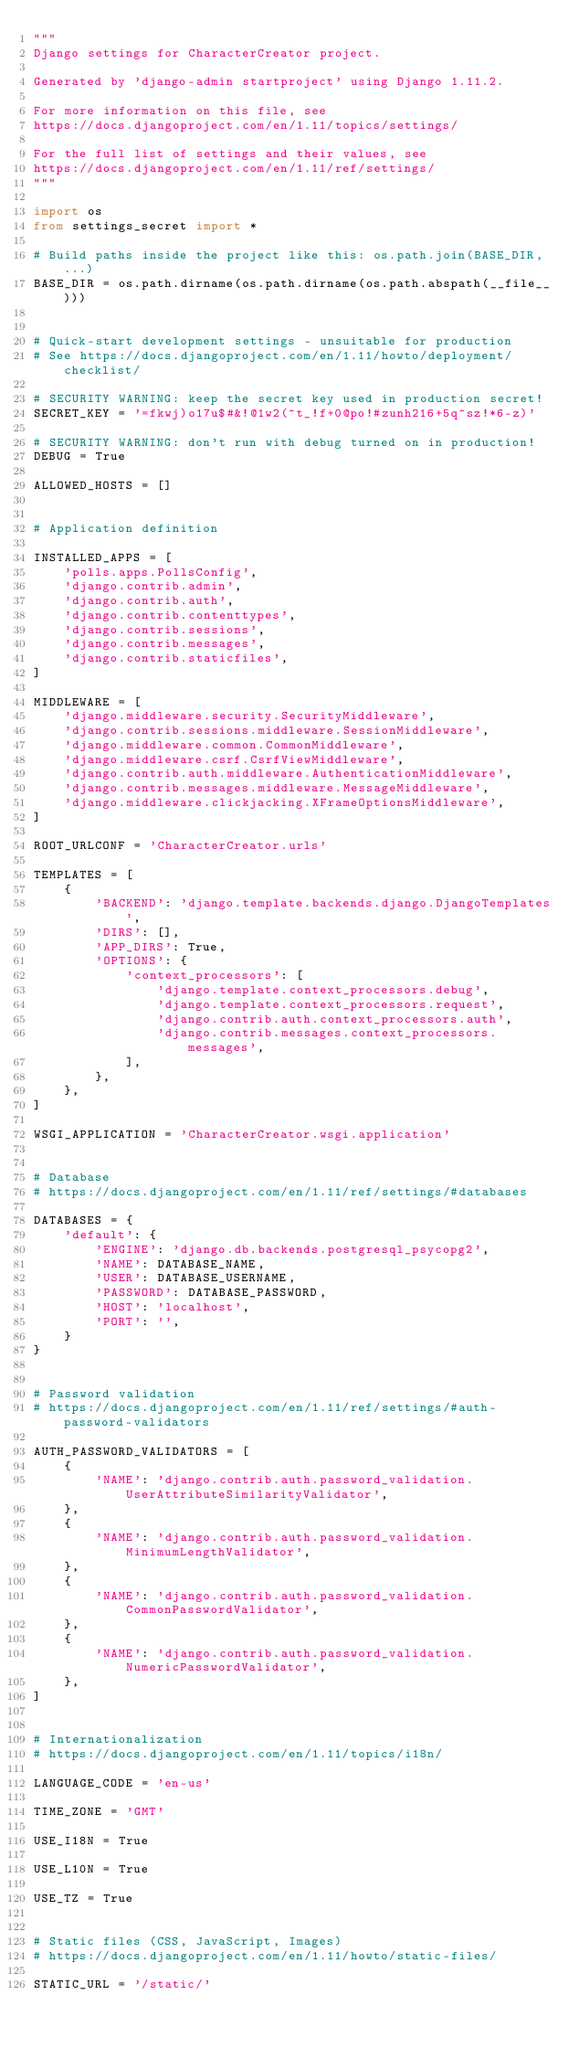<code> <loc_0><loc_0><loc_500><loc_500><_Python_>"""
Django settings for CharacterCreator project.

Generated by 'django-admin startproject' using Django 1.11.2.

For more information on this file, see
https://docs.djangoproject.com/en/1.11/topics/settings/

For the full list of settings and their values, see
https://docs.djangoproject.com/en/1.11/ref/settings/
"""

import os
from settings_secret import *

# Build paths inside the project like this: os.path.join(BASE_DIR, ...)
BASE_DIR = os.path.dirname(os.path.dirname(os.path.abspath(__file__)))


# Quick-start development settings - unsuitable for production
# See https://docs.djangoproject.com/en/1.11/howto/deployment/checklist/

# SECURITY WARNING: keep the secret key used in production secret!
SECRET_KEY = '=fkwj)o17u$#&!@1w2(^t_!f+0@po!#zunh216+5q^sz!*6-z)'

# SECURITY WARNING: don't run with debug turned on in production!
DEBUG = True

ALLOWED_HOSTS = []


# Application definition

INSTALLED_APPS = [
    'polls.apps.PollsConfig',
    'django.contrib.admin',
    'django.contrib.auth',
    'django.contrib.contenttypes',
    'django.contrib.sessions',
    'django.contrib.messages',
    'django.contrib.staticfiles',
]

MIDDLEWARE = [
    'django.middleware.security.SecurityMiddleware',
    'django.contrib.sessions.middleware.SessionMiddleware',
    'django.middleware.common.CommonMiddleware',
    'django.middleware.csrf.CsrfViewMiddleware',
    'django.contrib.auth.middleware.AuthenticationMiddleware',
    'django.contrib.messages.middleware.MessageMiddleware',
    'django.middleware.clickjacking.XFrameOptionsMiddleware',
]

ROOT_URLCONF = 'CharacterCreator.urls'

TEMPLATES = [
    {
        'BACKEND': 'django.template.backends.django.DjangoTemplates',
        'DIRS': [],
        'APP_DIRS': True,
        'OPTIONS': {
            'context_processors': [
                'django.template.context_processors.debug',
                'django.template.context_processors.request',
                'django.contrib.auth.context_processors.auth',
                'django.contrib.messages.context_processors.messages',
            ],
        },
    },
]

WSGI_APPLICATION = 'CharacterCreator.wsgi.application'


# Database
# https://docs.djangoproject.com/en/1.11/ref/settings/#databases

DATABASES = {
    'default': {
        'ENGINE': 'django.db.backends.postgresql_psycopg2',
        'NAME': DATABASE_NAME,
        'USER': DATABASE_USERNAME,
        'PASSWORD': DATABASE_PASSWORD,
        'HOST': 'localhost',
        'PORT': '',
    }
}


# Password validation
# https://docs.djangoproject.com/en/1.11/ref/settings/#auth-password-validators

AUTH_PASSWORD_VALIDATORS = [
    {
        'NAME': 'django.contrib.auth.password_validation.UserAttributeSimilarityValidator',
    },
    {
        'NAME': 'django.contrib.auth.password_validation.MinimumLengthValidator',
    },
    {
        'NAME': 'django.contrib.auth.password_validation.CommonPasswordValidator',
    },
    {
        'NAME': 'django.contrib.auth.password_validation.NumericPasswordValidator',
    },
]


# Internationalization
# https://docs.djangoproject.com/en/1.11/topics/i18n/

LANGUAGE_CODE = 'en-us'

TIME_ZONE = 'GMT'

USE_I18N = True

USE_L10N = True

USE_TZ = True


# Static files (CSS, JavaScript, Images)
# https://docs.djangoproject.com/en/1.11/howto/static-files/

STATIC_URL = '/static/'
</code> 